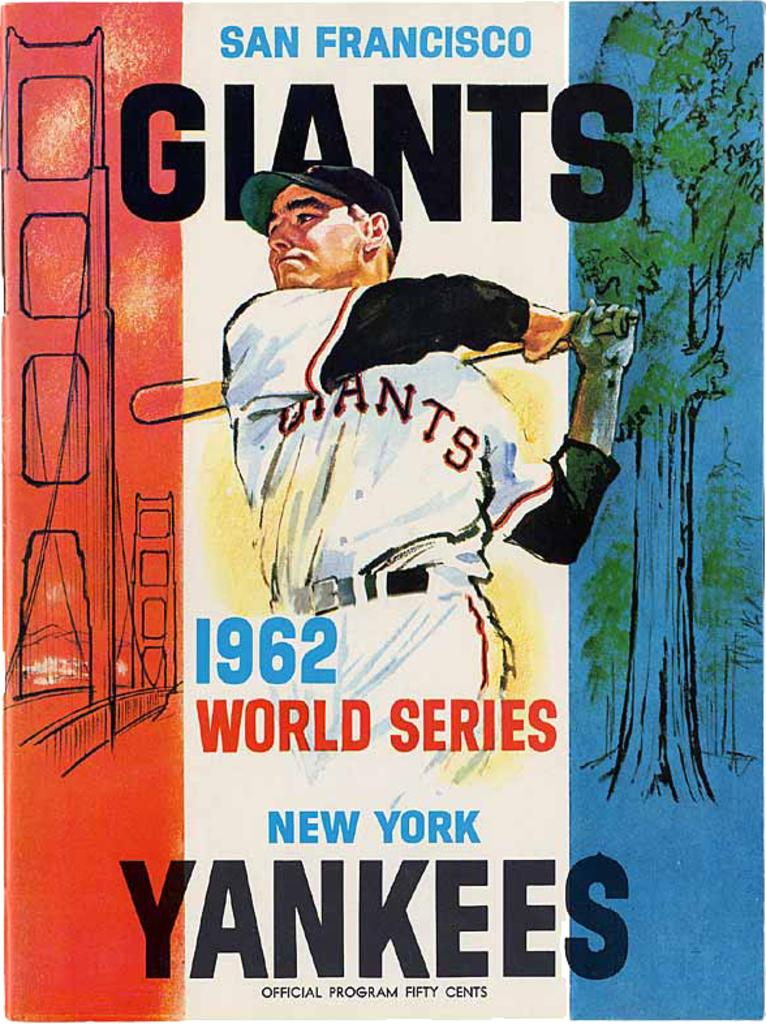<image>
Offer a succinct explanation of the picture presented. Vintage 1962 illustrated world series Baseball poster for San Franisco Giants and the New York Yankees. 